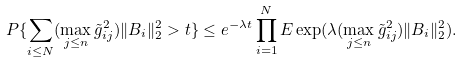<formula> <loc_0><loc_0><loc_500><loc_500>P \{ \sum _ { i \leq N } ( \max _ { j \leq n } \tilde { g } _ { i j } ^ { 2 } ) \| B _ { i } \| _ { 2 } ^ { 2 } > t \} \leq e ^ { - \lambda t } \prod _ { i = 1 } ^ { N } E \exp ( \lambda ( \max _ { j \leq n } \tilde { g } _ { i j } ^ { 2 } ) \| B _ { i } \| _ { 2 } ^ { 2 } ) .</formula> 